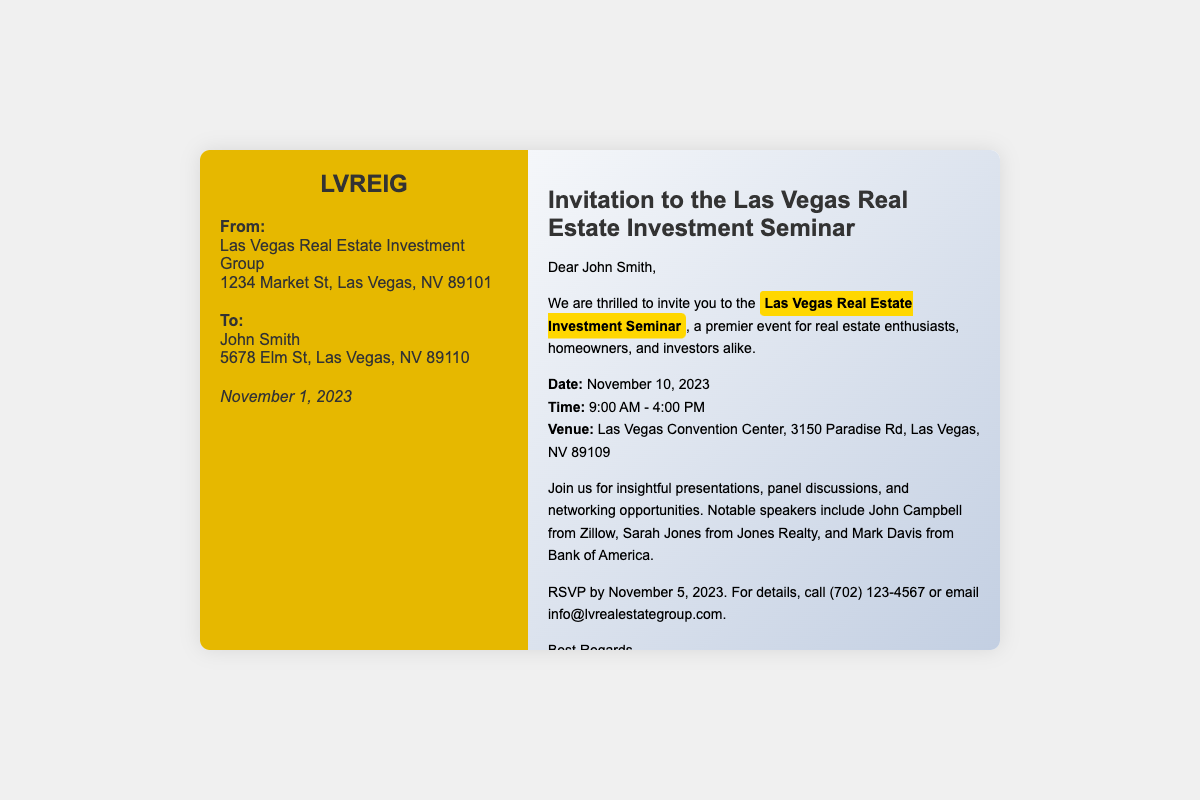What is the date of the seminar? The seminar is scheduled for November 10, 2023, as mentioned in the document.
Answer: November 10, 2023 Who is the sender of the invitation? The invitation is sent by the Las Vegas Real Estate Investment Group, which is listed in the sender section.
Answer: Las Vegas Real Estate Investment Group What time does the seminar start? The starting time of the seminar is specified as 9:00 AM in the document.
Answer: 9:00 AM Where will the seminar take place? The venue for the seminar is mentioned as Las Vegas Convention Center, which is part of the details provided.
Answer: Las Vegas Convention Center What is the RSVP deadline? The document indicates that the RSVP needs to be sent by November 5, 2023.
Answer: November 5, 2023 Who are some notable speakers at the seminar? The document lists John Campbell, Sarah Jones, and Mark Davis as notable speakers at the event.
Answer: John Campbell, Sarah Jones, Mark Davis What is the purpose of the seminar? The seminar is described as a premier event for real estate enthusiasts, homeowners, and investors, indicating its purpose.
Answer: Premier event for real estate enthusiasts What is the phone number to call for more details? The document provides the contact number (702) 123-4567 for inquiries about the seminar.
Answer: (702) 123-4567 How long does the seminar last? The duration of the seminar is from 9:00 AM to 4:00 PM, which means it lasts for 7 hours.
Answer: 7 hours 